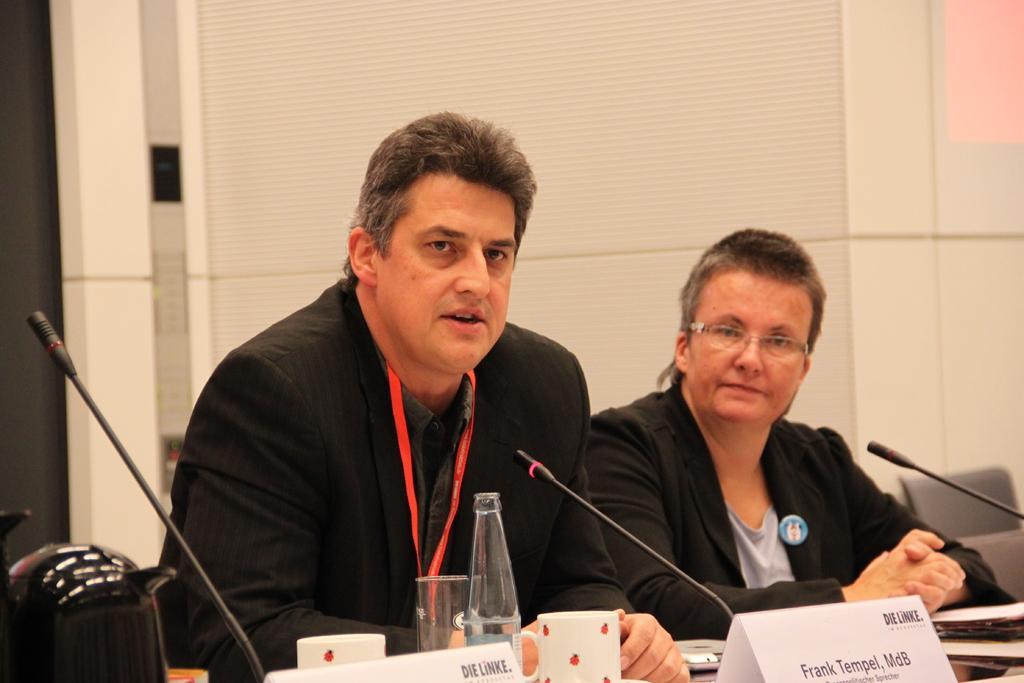Can you describe this image briefly? In this picture I can see couple of them sitting on the chairs. I can see a bottle, couple of cups, a glass and I can see a laptop and couple of name boards with some text on the tables. I can see microphones and pa kettle on the left side and a wall in the background. 